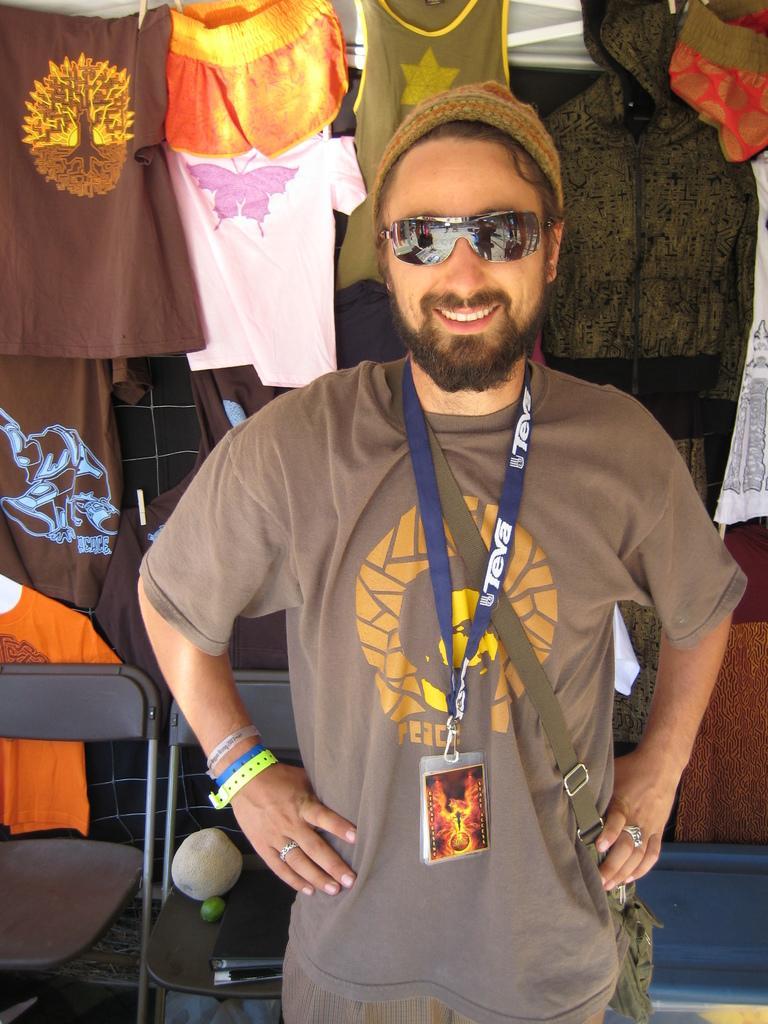How would you summarize this image in a sentence or two? As we can see in the image there are clots, chairs, a man wearing goggles, cap and brown color t shirt and id card. 